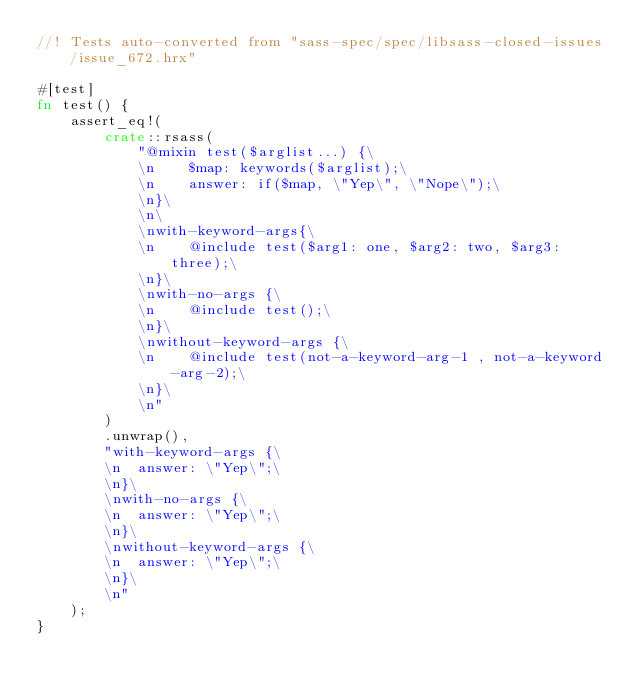<code> <loc_0><loc_0><loc_500><loc_500><_Rust_>//! Tests auto-converted from "sass-spec/spec/libsass-closed-issues/issue_672.hrx"

#[test]
fn test() {
    assert_eq!(
        crate::rsass(
            "@mixin test($arglist...) {\
            \n    $map: keywords($arglist);\
            \n    answer: if($map, \"Yep\", \"Nope\");\
            \n}\
            \n\
            \nwith-keyword-args{\
            \n    @include test($arg1: one, $arg2: two, $arg3: three);\
            \n}\
            \nwith-no-args {\
            \n    @include test();\
            \n}\
            \nwithout-keyword-args {\
            \n    @include test(not-a-keyword-arg-1 , not-a-keyword-arg-2);\
            \n}\
            \n"
        )
        .unwrap(),
        "with-keyword-args {\
        \n  answer: \"Yep\";\
        \n}\
        \nwith-no-args {\
        \n  answer: \"Yep\";\
        \n}\
        \nwithout-keyword-args {\
        \n  answer: \"Yep\";\
        \n}\
        \n"
    );
}
</code> 